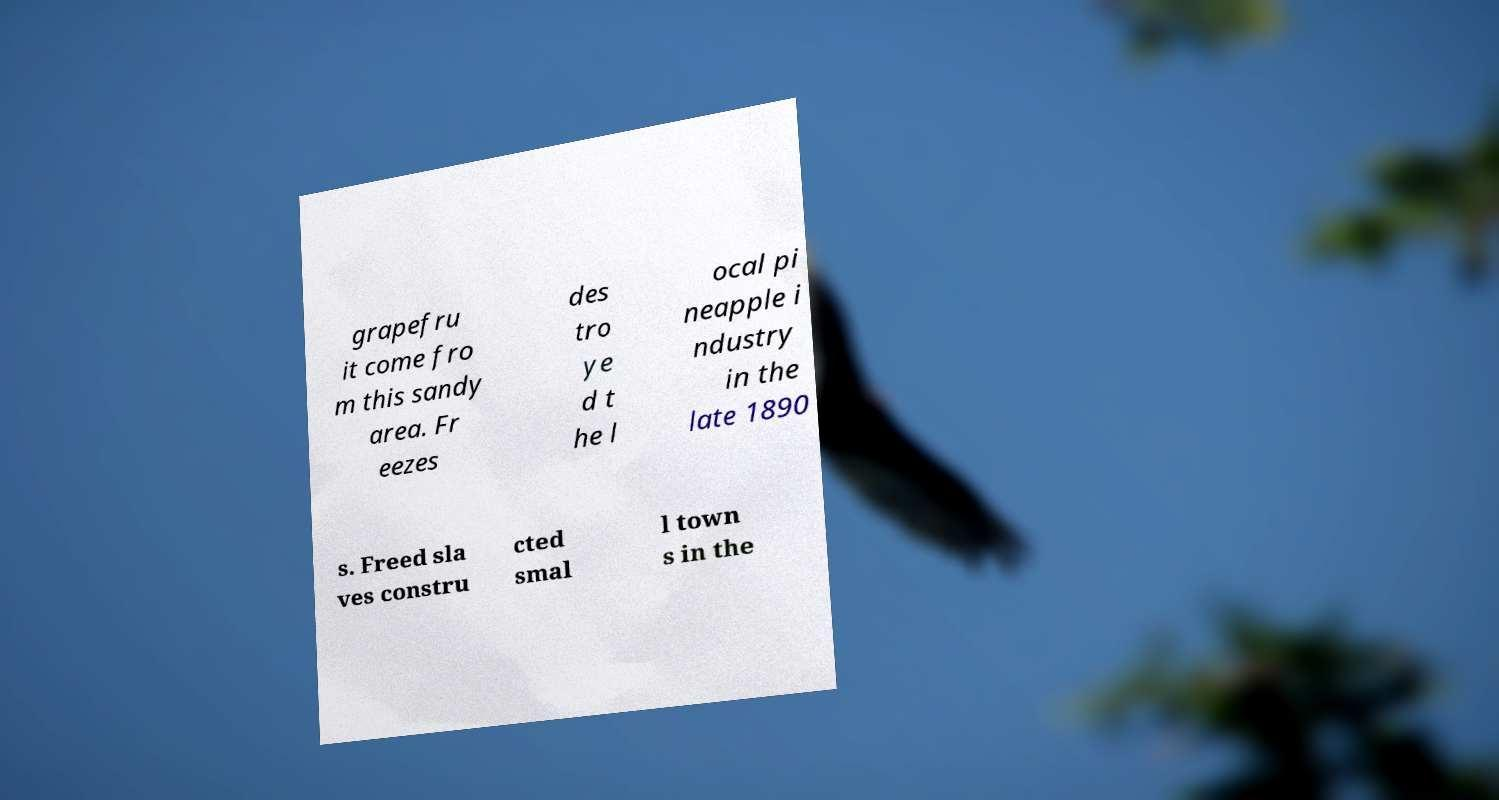Please read and relay the text visible in this image. What does it say? grapefru it come fro m this sandy area. Fr eezes des tro ye d t he l ocal pi neapple i ndustry in the late 1890 s. Freed sla ves constru cted smal l town s in the 